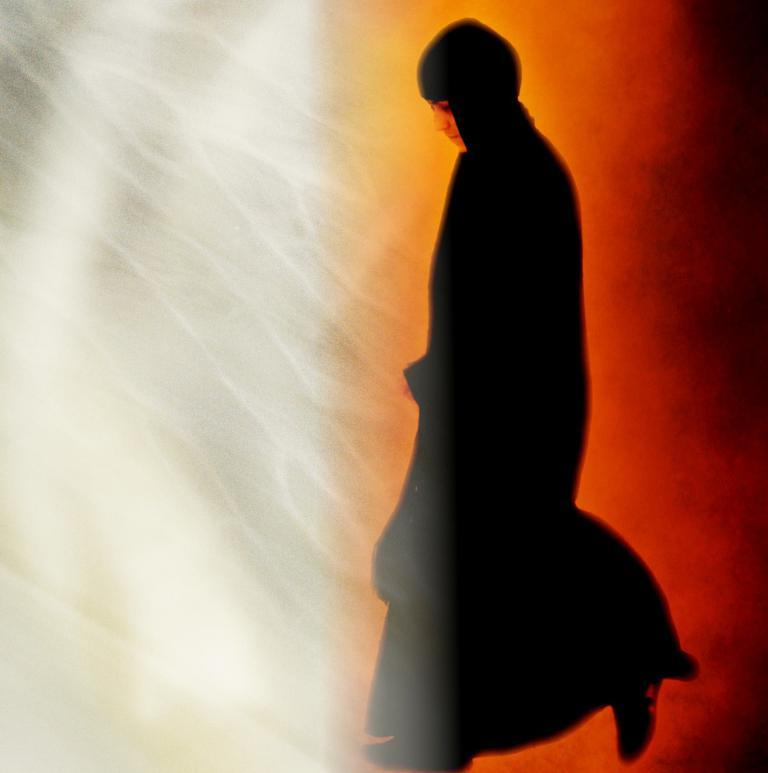What type of image is being described? The image is an edited picture. Can you describe the main subject in the image? There is a person in the image. What is the person wearing? The person is wearing a black dress. How many eggs are visible in the yard in the image? There is no yard or eggs present in the image; it features an edited picture of a person wearing a black dress. 